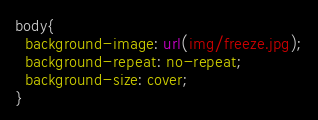Convert code to text. <code><loc_0><loc_0><loc_500><loc_500><_CSS_>body{
  background-image: url(img/freeze.jpg);
  background-repeat: no-repeat;
  background-size: cover;
}
</code> 